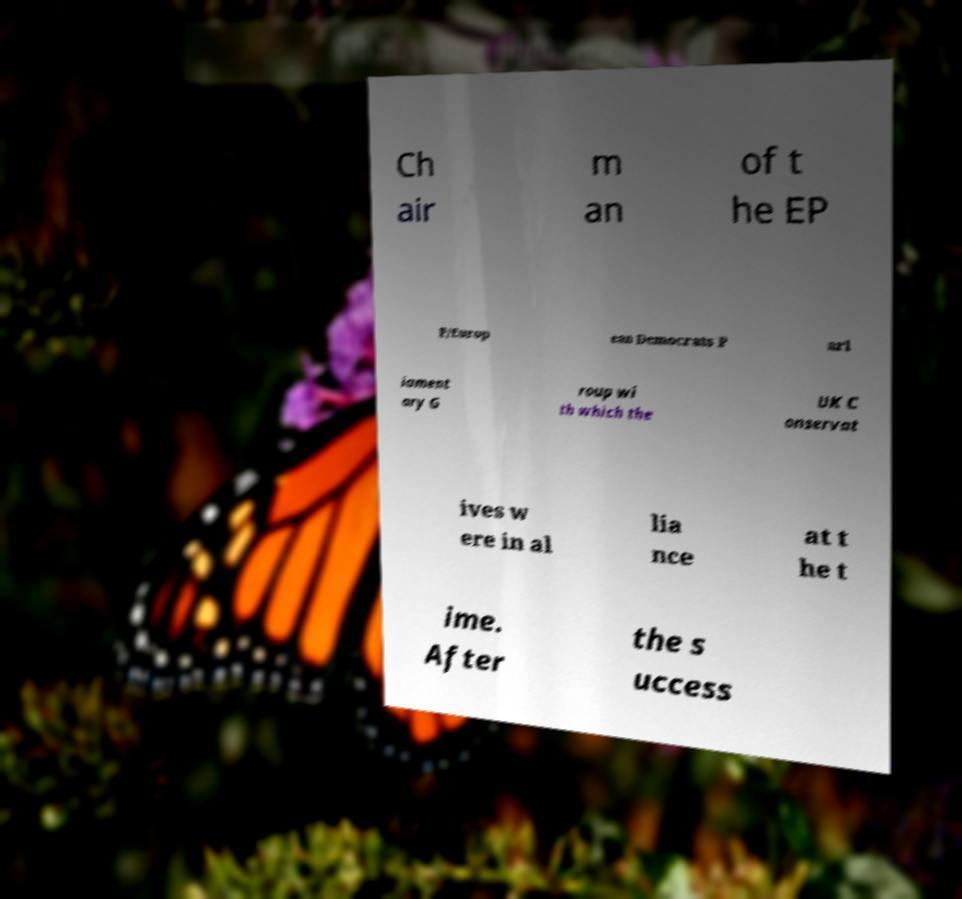For documentation purposes, I need the text within this image transcribed. Could you provide that? Ch air m an of t he EP P/Europ ean Democrats P arl iament ary G roup wi th which the UK C onservat ives w ere in al lia nce at t he t ime. After the s uccess 